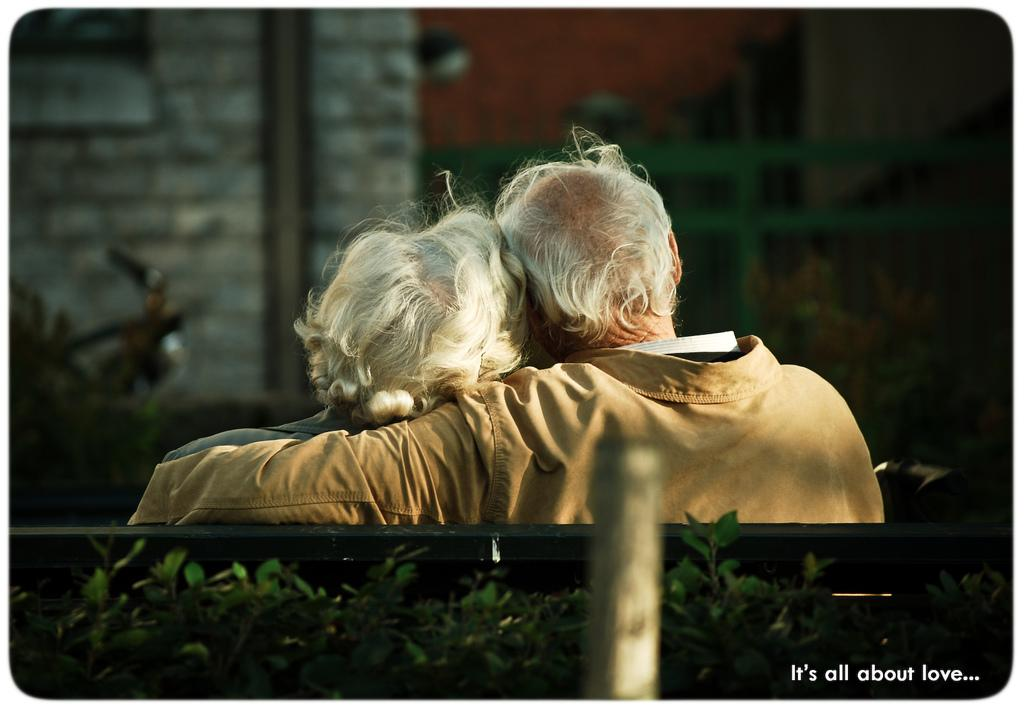How many people are sitting on the bench in the image? There are two persons sitting on a bench in the image. What else can be seen in the image besides the people on the bench? There are plants, poles, lights, and buildings in the image. What type of fog can be seen surrounding the buildings in the image? There is no fog present in the image; the buildings are clearly visible. Who is the owner of the sidewalk in the image? There is no specific sidewalk mentioned in the image, and ownership cannot be determined from the image alone. 